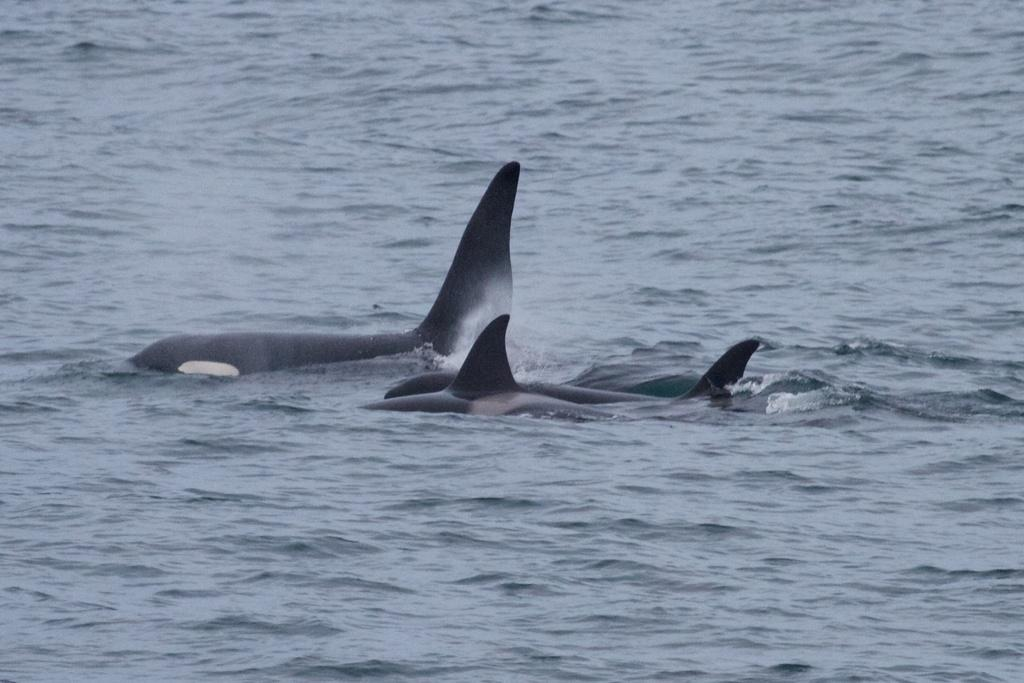What type of animals can be seen in the water in the image? There are fish in the water in the image. What type of bed can be seen floating on the water in the image? There is no bed present in the image; it only features fish in the water. 